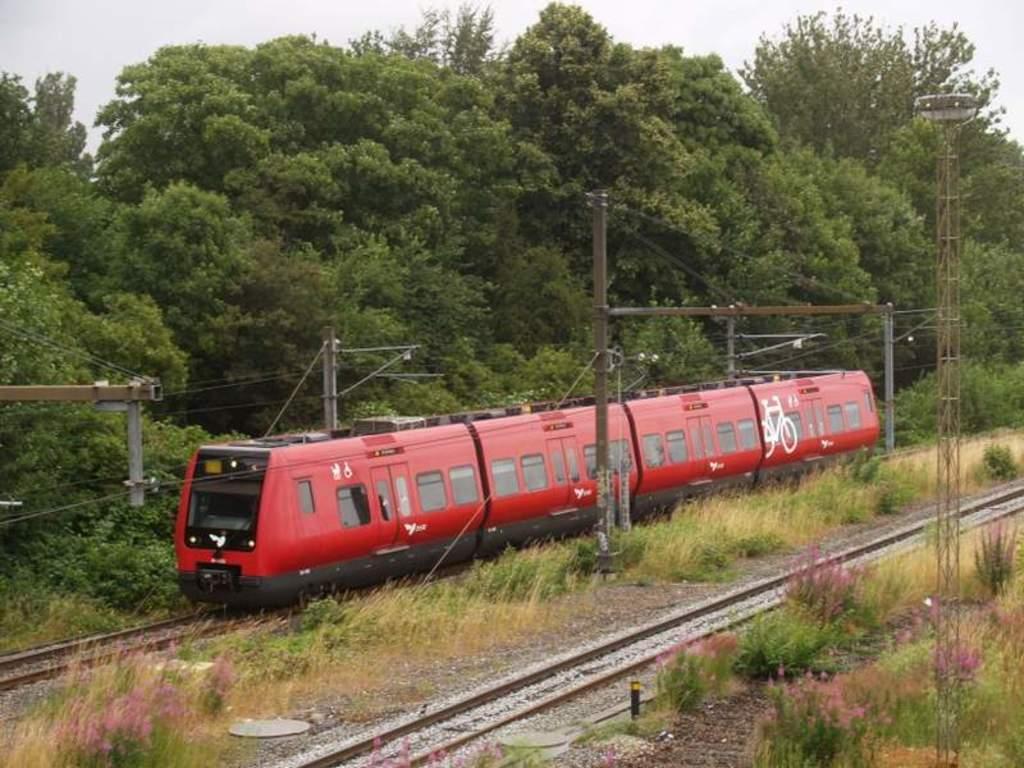Please provide a concise description of this image. Train is on the track. Here we can see grass, poles and trees. 